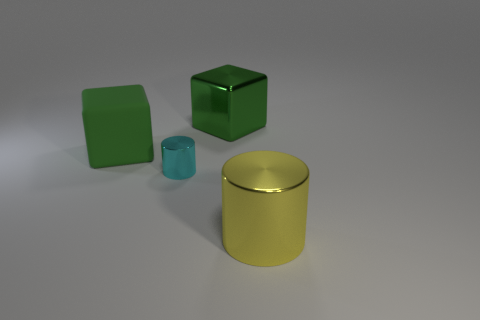What material is the green thing that is the same size as the metal cube?
Offer a very short reply. Rubber. There is a thing that is both in front of the big matte thing and behind the large yellow metal cylinder; what size is it?
Your answer should be very brief. Small. What size is the cyan shiny thing that is the same shape as the big yellow object?
Provide a short and direct response. Small. How many things are either brown metallic balls or green objects that are right of the small metal cylinder?
Ensure brevity in your answer.  1. The green metal object is what shape?
Offer a very short reply. Cube. What is the shape of the green object to the left of the green cube that is behind the matte thing?
Ensure brevity in your answer.  Cube. What is the material of the big block that is the same color as the large matte object?
Your answer should be compact. Metal. What is the color of the other cylinder that is the same material as the cyan cylinder?
Make the answer very short. Yellow. Is there anything else that is the same size as the green rubber cube?
Make the answer very short. Yes. There is a large shiny thing that is behind the large yellow metal object; does it have the same color as the cylinder that is on the left side of the yellow cylinder?
Provide a short and direct response. No. 